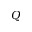<formula> <loc_0><loc_0><loc_500><loc_500>Q</formula> 